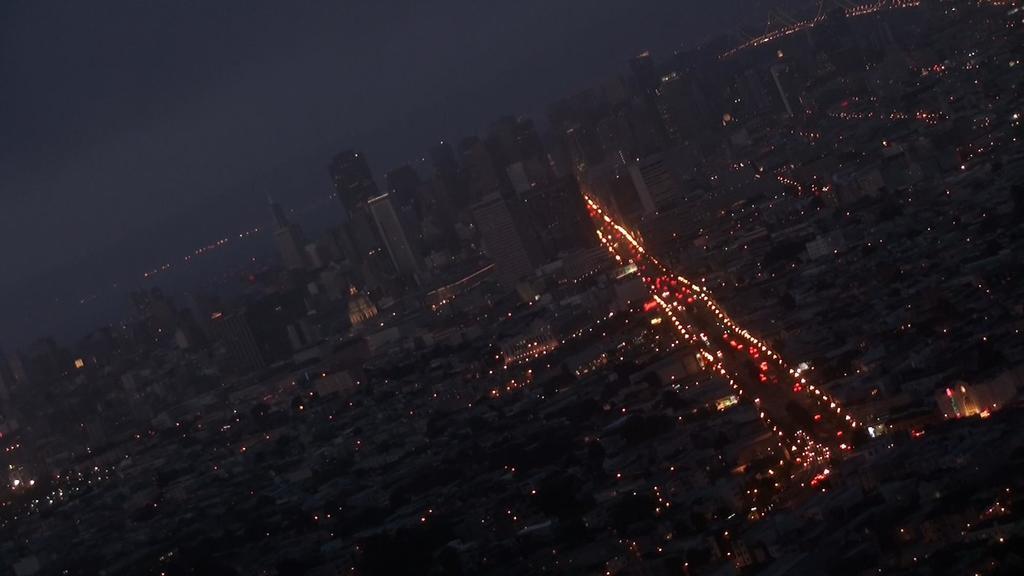In one or two sentences, can you explain what this image depicts? In this image there are buildings and there are lights. 